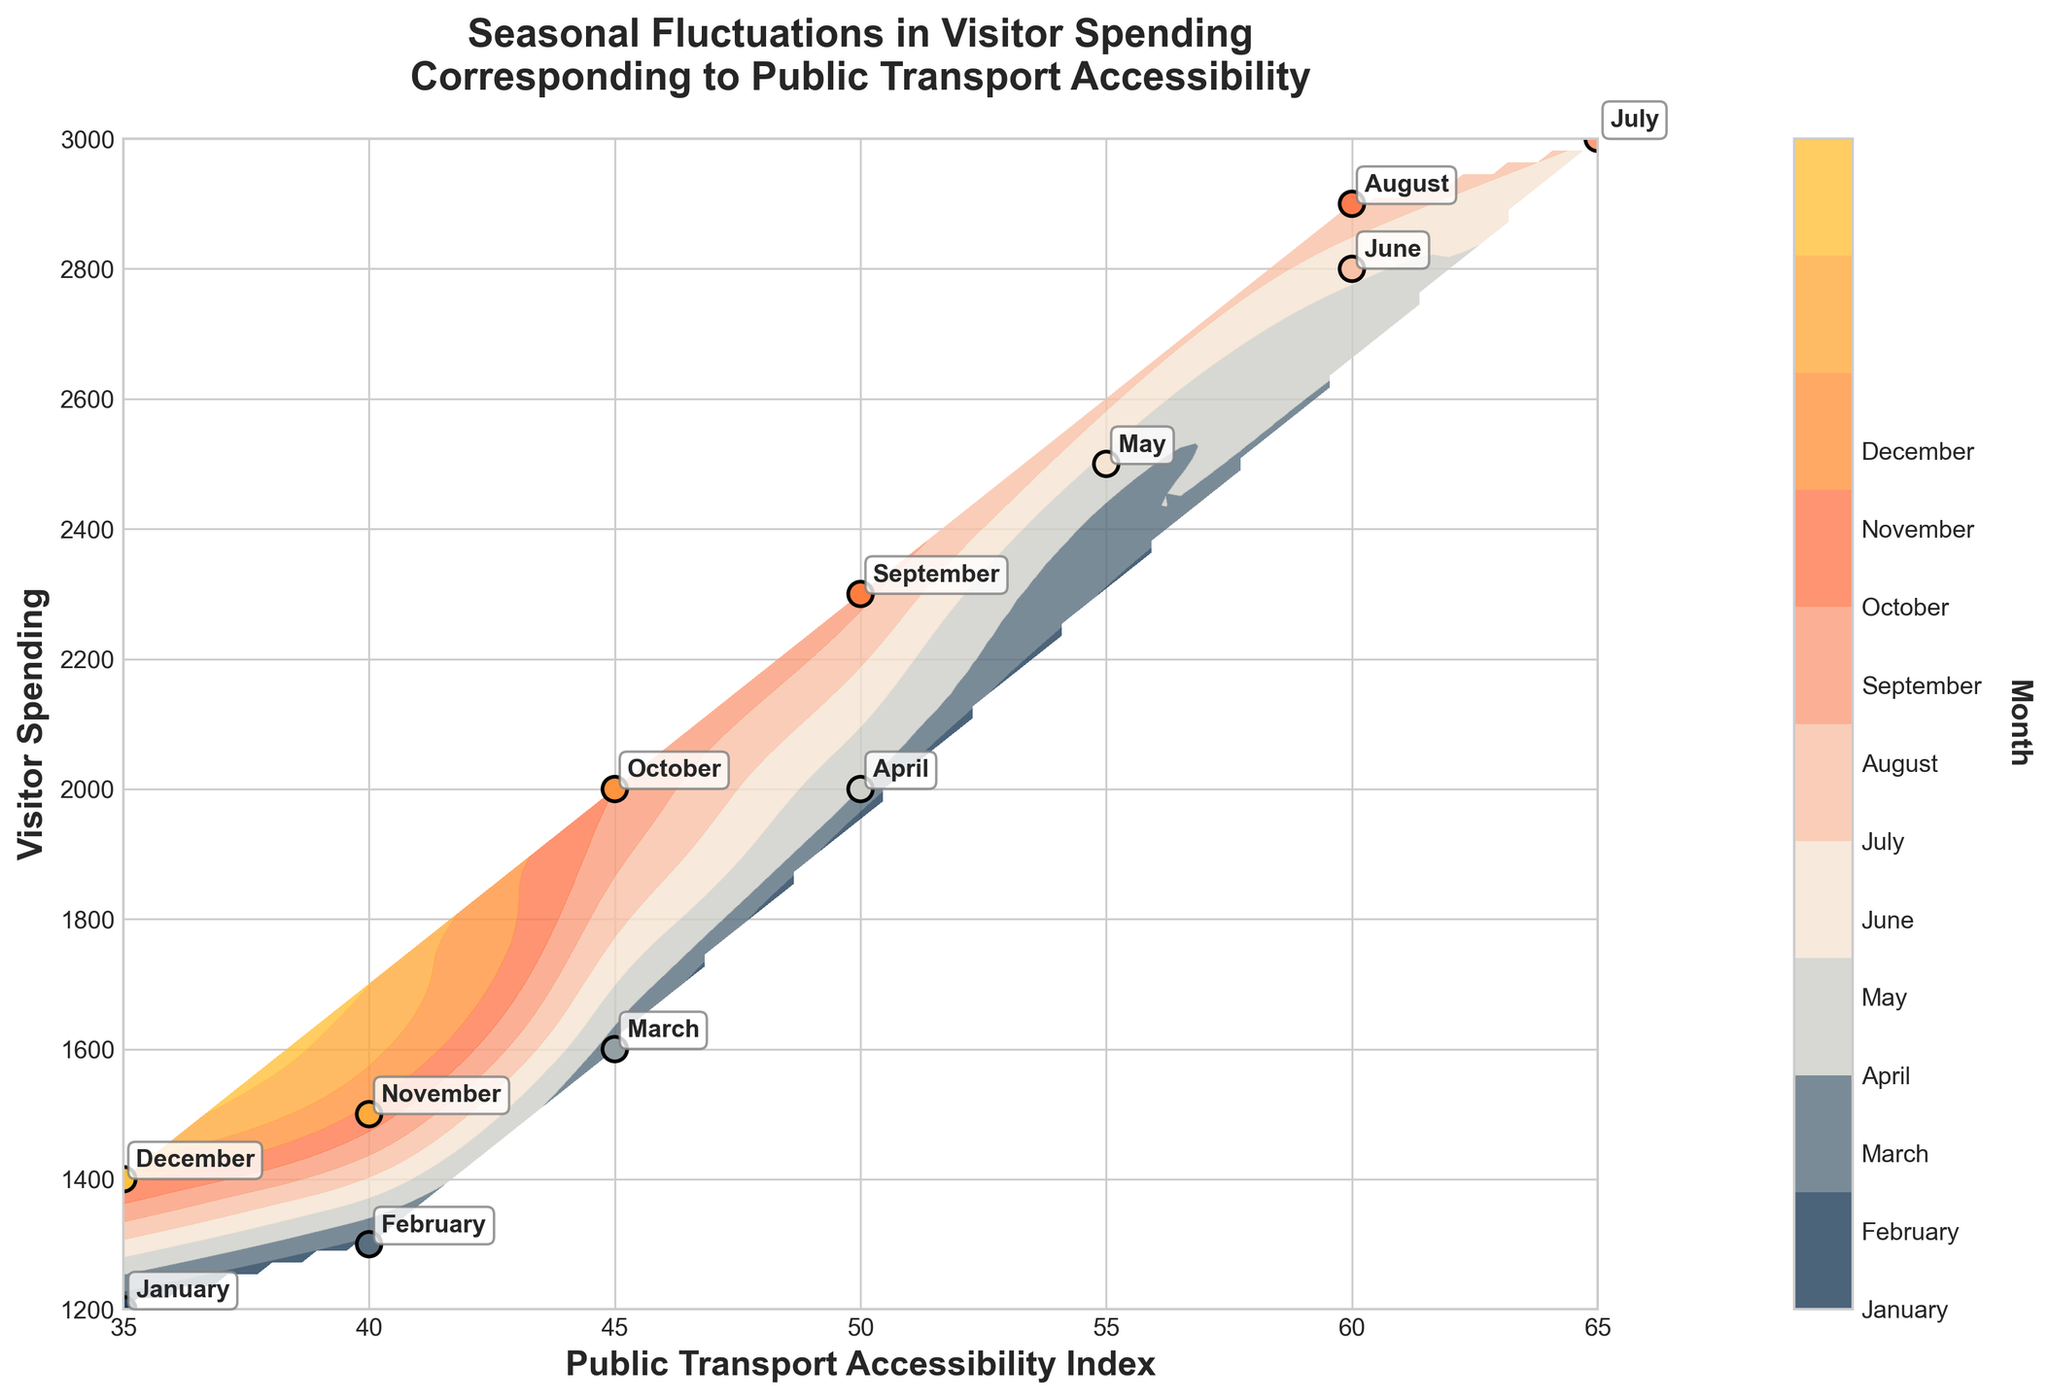What is the title of the plot? The title is written at the top center of the plot and reads "Seasonal Fluctuations in Visitor Spending Corresponding to Public Transport Accessibility".
Answer: Seasonal Fluctuations in Visitor Spending Corresponding to Public Transport Accessibility What are the labels on the X and Y axes? The labels are found along the axes. The X-axis is labeled "Public Transport Accessibility Index" and the Y-axis is labeled "Visitor Spending".
Answer: Public Transport Accessibility Index, Visitor Spending Which month has the highest visitor spending? From the visual data points and annotated labels, July has the highest visitor spending of 3000.
Answer: July During which months is the Public Transport Accessibility Index the lowest? Look for the months with the smallest values on the x-axis. Both January and December have the lowest Public Transport Accessibility Index of 35.
Answer: January, December Which month shows the most significant increase in visitor spending compared to the previous month? Compare the visitor spending of consecutive months and look for the largest increase. The largest increase is between April and May, from 2000 to 2500.
Answer: May What is the color of the contour corresponding to months with the least visitor spending? The contour color for the least visitor spending (January, December) can be identified from the color gradient on the plot. It is a dark blue color.
Answer: Dark blue What trend do you observe between Public Transport Accessibility and Visitor Spending? By analyzing the overall pattern of the data points, observe that as the Public Transport Accessibility Index increases, visitor spending generally increases as well.
Answer: Positive correlation Compared to October, does March have higher or lower visitor spending and accessibility index? By comparing the labels and positions of October and March, March has higher values both in visitor spending (1600 vs 2000) and Public Transport Accessibility Index (45 vs 50).
Answer: Higher How does visitor spending in August compare to June? By looking at the plot data points and labels for June and August, June’s visitor spending is slightly higher (2900 vs 2800).
Answer: Higher What can you infer about public transport accessibility and visitor spending during peak months of tourism? Based on the data points for June, July, and August (peak months with highest spending), these months also show higher Public Transport Accessibility Index (60-65).
Answer: Higher accessibility, higher spending 